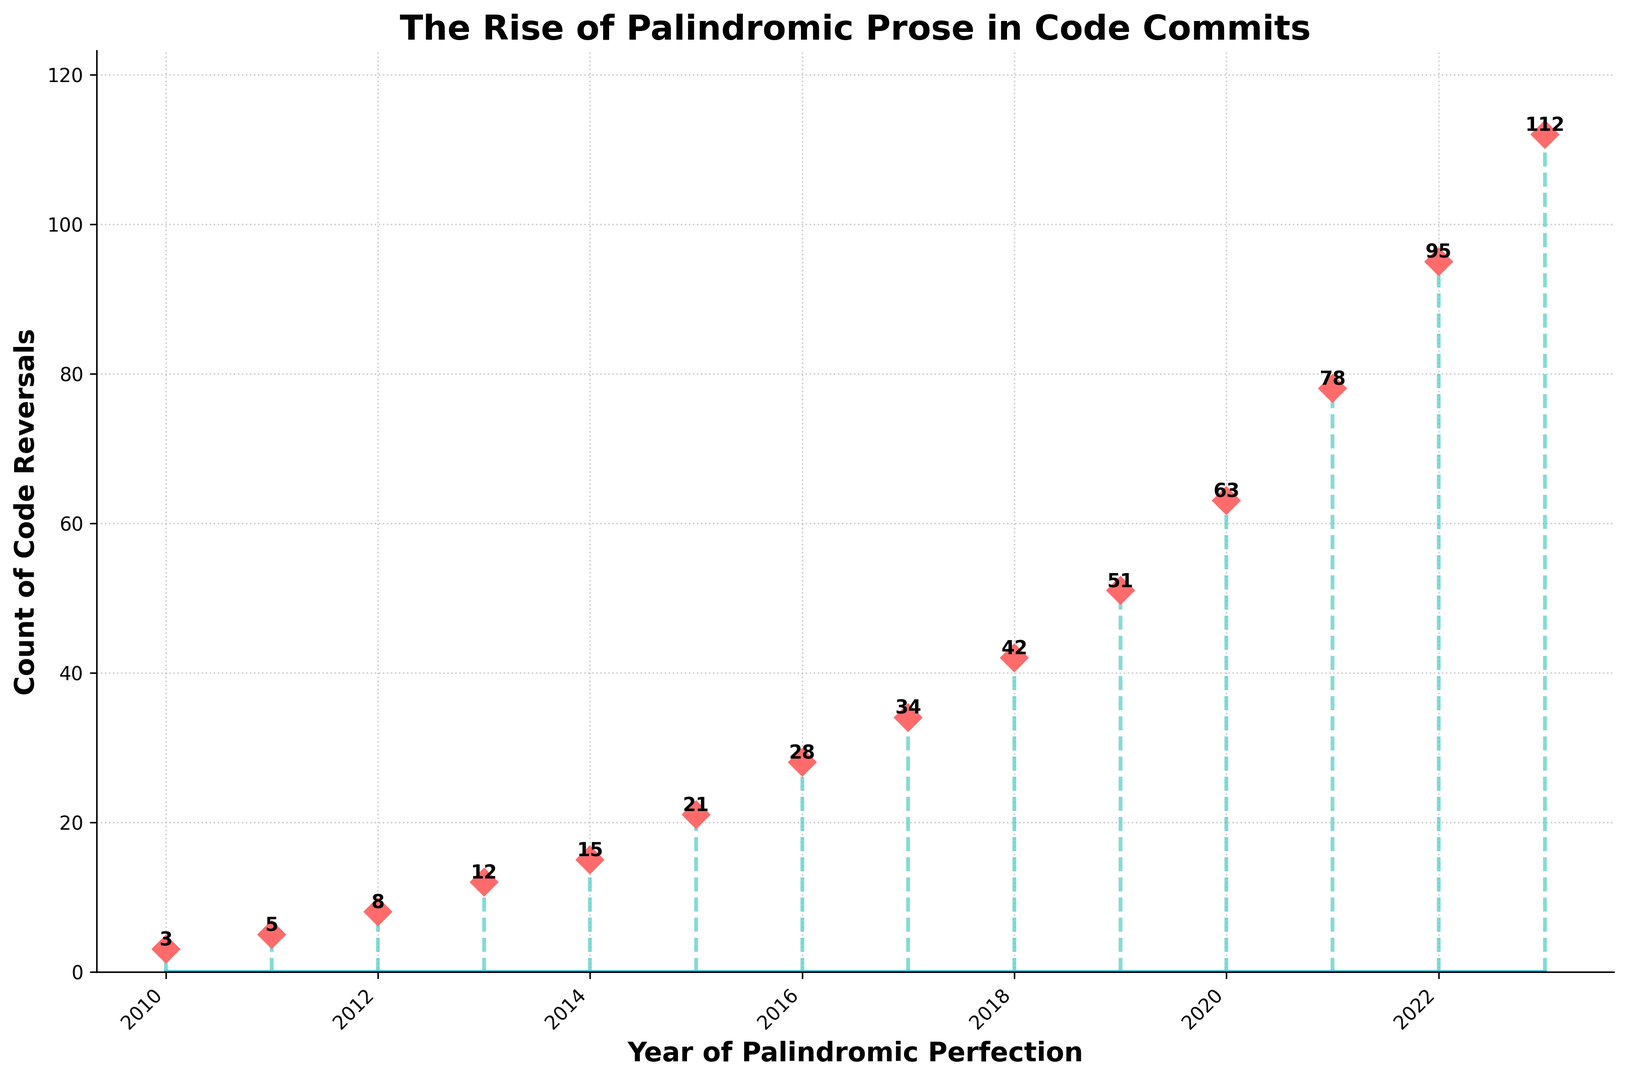What's the occurrence count in the year 2017? Locate the year 2017 on the x-axis and look at the corresponding point on the y-axis. The plotted point shows an occurrence count of 34.
Answer: 34 Which year saw the greatest increase in palindromic commit messages compared to the previous year? Calculate the yearly increase by subtracting the previous year's count from the current year's count for each pair of consecutive years. The greatest increase is seen between 2020 (63) and 2021 (78) with an increase of 15.
Answer: 2021 What is the average occurrence count for the years 2015, 2016, and 2017? Sum the occurrences for 2015, 2016, and 2017 (21 + 28 + 34) and divide by 3. This results in (21 + 28 + 34) / 3 = 83 / 3 = approximately 27.67.
Answer: 27.67 Between which two consecutive years was the smallest increase in palindromic commit messages? Calculate the difference between consecutive years: 2010-11: 2, 2011-12: 3, 2012-13: 4, 2013-14: 3, 2014-15: 6, 2015-16: 7, 2016-17: 6, 2017-18: 8, 2018-19: 9, 2019-20: 12, 2020-21: 15, 2021-22: 17, 2022-23: 17. The smallest increase is 2, which occurred between 2010 and 2011.
Answer: 2010-2011 How many occurrences were there in the first three years combined? Sum the occurrences for the first three years: 2010 (3) + 2011 (5) + 2012 (8). So, 3 + 5 + 8 = 16.
Answer: 16 Was there ever a decrease in occurrences of palindromic commit messages? Examine the year-over-year changes in the plot. The trend is always increasing; hence, there never was a decrease in occurrences.
Answer: No What visual attributes are used to differentiate stem lines and markers? Observe the figure and note that the stem lines are green and dashed while the markers are red diamonds.
Answer: Green dashed lines and red diamond markers Which year marks the halfway point in the data set and how many occurrences are there in that year? The data spans 14 years from 2010 to 2023. The halfway point would be the 7th year, which is 2016. In 2016, the occurrence count is 28.
Answer: 2016, 28 